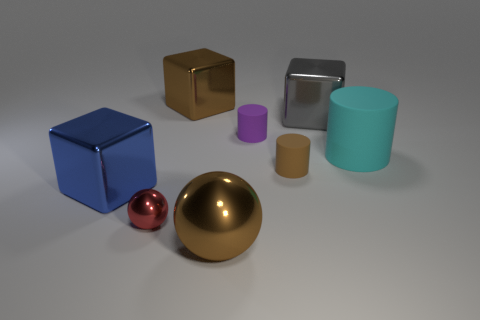Subtract all yellow cylinders. Subtract all yellow spheres. How many cylinders are left? 3 Add 1 large shiny cubes. How many objects exist? 9 Subtract all balls. How many objects are left? 6 Add 3 spheres. How many spheres are left? 5 Add 8 large blue shiny things. How many large blue shiny things exist? 9 Subtract 0 blue cylinders. How many objects are left? 8 Subtract all large red matte objects. Subtract all large cyan matte things. How many objects are left? 7 